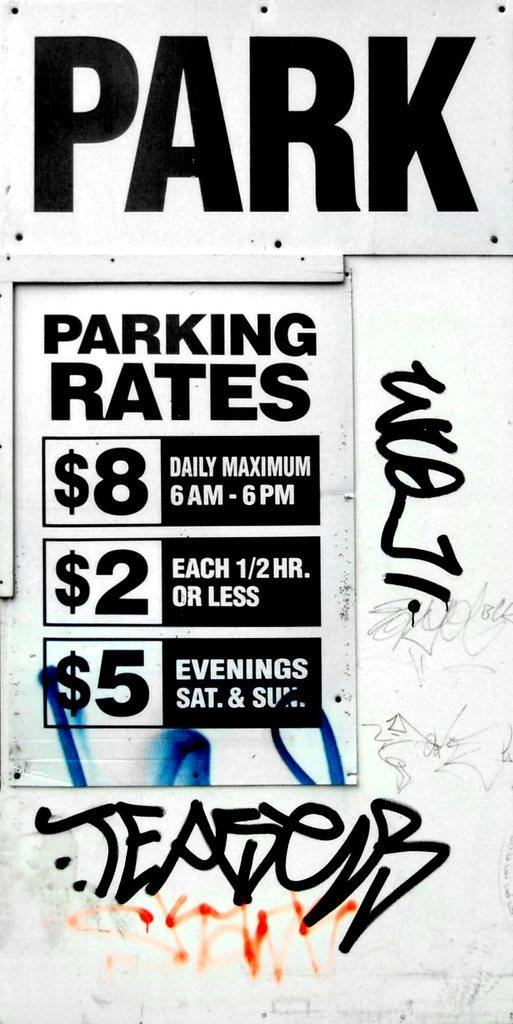<image>
Summarize the visual content of the image. The sign explains the parking rates prices between 6am and 6 pm and at the evenings. 